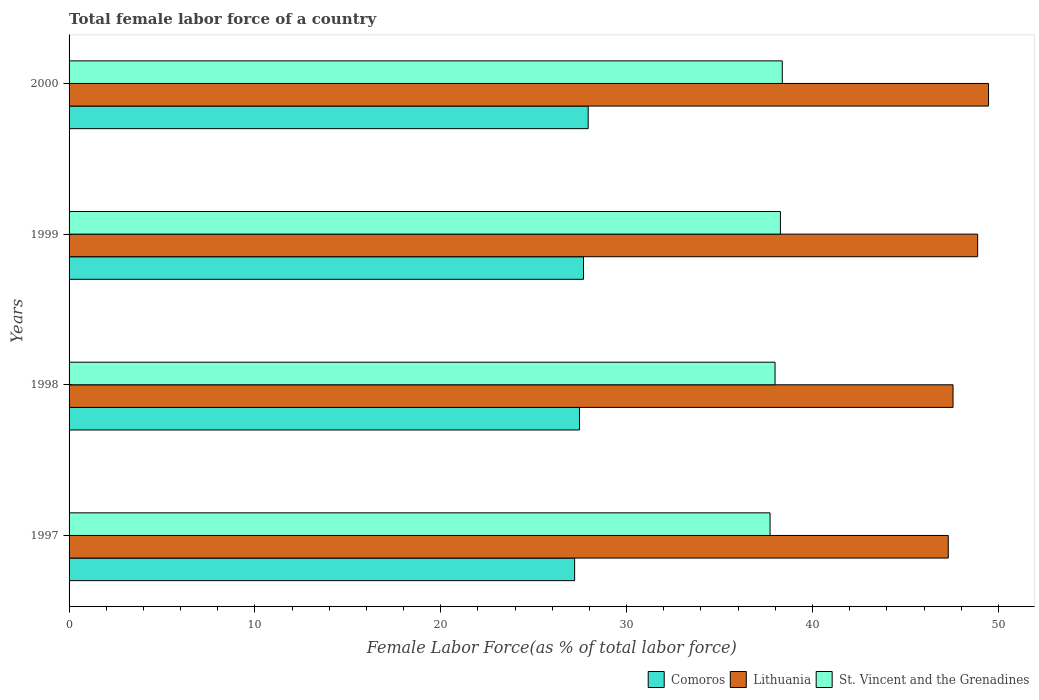How many different coloured bars are there?
Offer a very short reply. 3. How many bars are there on the 2nd tick from the top?
Your response must be concise. 3. What is the label of the 3rd group of bars from the top?
Make the answer very short. 1998. What is the percentage of female labor force in Lithuania in 1997?
Make the answer very short. 47.31. Across all years, what is the maximum percentage of female labor force in Lithuania?
Offer a terse response. 49.47. Across all years, what is the minimum percentage of female labor force in Lithuania?
Your answer should be compact. 47.31. What is the total percentage of female labor force in Lithuania in the graph?
Ensure brevity in your answer.  193.22. What is the difference between the percentage of female labor force in Comoros in 1997 and that in 1999?
Keep it short and to the point. -0.48. What is the difference between the percentage of female labor force in Lithuania in 1998 and the percentage of female labor force in Comoros in 1999?
Offer a terse response. 19.88. What is the average percentage of female labor force in Comoros per year?
Offer a very short reply. 27.57. In the year 1998, what is the difference between the percentage of female labor force in Comoros and percentage of female labor force in Lithuania?
Offer a terse response. -20.1. What is the ratio of the percentage of female labor force in Lithuania in 1999 to that in 2000?
Your answer should be compact. 0.99. Is the difference between the percentage of female labor force in Comoros in 1999 and 2000 greater than the difference between the percentage of female labor force in Lithuania in 1999 and 2000?
Provide a succinct answer. Yes. What is the difference between the highest and the second highest percentage of female labor force in St. Vincent and the Grenadines?
Provide a succinct answer. 0.1. What is the difference between the highest and the lowest percentage of female labor force in Comoros?
Offer a very short reply. 0.73. What does the 1st bar from the top in 1999 represents?
Ensure brevity in your answer.  St. Vincent and the Grenadines. What does the 1st bar from the bottom in 2000 represents?
Your answer should be very brief. Comoros. Is it the case that in every year, the sum of the percentage of female labor force in Lithuania and percentage of female labor force in St. Vincent and the Grenadines is greater than the percentage of female labor force in Comoros?
Your response must be concise. Yes. How many bars are there?
Provide a succinct answer. 12. What is the difference between two consecutive major ticks on the X-axis?
Offer a terse response. 10. Are the values on the major ticks of X-axis written in scientific E-notation?
Provide a short and direct response. No. Does the graph contain any zero values?
Offer a terse response. No. Where does the legend appear in the graph?
Your answer should be compact. Bottom right. How are the legend labels stacked?
Offer a terse response. Horizontal. What is the title of the graph?
Ensure brevity in your answer.  Total female labor force of a country. What is the label or title of the X-axis?
Offer a very short reply. Female Labor Force(as % of total labor force). What is the Female Labor Force(as % of total labor force) of Comoros in 1997?
Your response must be concise. 27.2. What is the Female Labor Force(as % of total labor force) in Lithuania in 1997?
Your response must be concise. 47.31. What is the Female Labor Force(as % of total labor force) in St. Vincent and the Grenadines in 1997?
Ensure brevity in your answer.  37.72. What is the Female Labor Force(as % of total labor force) of Comoros in 1998?
Keep it short and to the point. 27.47. What is the Female Labor Force(as % of total labor force) of Lithuania in 1998?
Provide a short and direct response. 47.56. What is the Female Labor Force(as % of total labor force) of St. Vincent and the Grenadines in 1998?
Your response must be concise. 37.99. What is the Female Labor Force(as % of total labor force) in Comoros in 1999?
Ensure brevity in your answer.  27.68. What is the Female Labor Force(as % of total labor force) of Lithuania in 1999?
Provide a short and direct response. 48.89. What is the Female Labor Force(as % of total labor force) in St. Vincent and the Grenadines in 1999?
Provide a short and direct response. 38.27. What is the Female Labor Force(as % of total labor force) of Comoros in 2000?
Provide a succinct answer. 27.93. What is the Female Labor Force(as % of total labor force) in Lithuania in 2000?
Make the answer very short. 49.47. What is the Female Labor Force(as % of total labor force) of St. Vincent and the Grenadines in 2000?
Provide a short and direct response. 38.37. Across all years, what is the maximum Female Labor Force(as % of total labor force) of Comoros?
Offer a terse response. 27.93. Across all years, what is the maximum Female Labor Force(as % of total labor force) in Lithuania?
Make the answer very short. 49.47. Across all years, what is the maximum Female Labor Force(as % of total labor force) in St. Vincent and the Grenadines?
Make the answer very short. 38.37. Across all years, what is the minimum Female Labor Force(as % of total labor force) in Comoros?
Provide a short and direct response. 27.2. Across all years, what is the minimum Female Labor Force(as % of total labor force) of Lithuania?
Provide a succinct answer. 47.31. Across all years, what is the minimum Female Labor Force(as % of total labor force) in St. Vincent and the Grenadines?
Your response must be concise. 37.72. What is the total Female Labor Force(as % of total labor force) of Comoros in the graph?
Your response must be concise. 110.28. What is the total Female Labor Force(as % of total labor force) in Lithuania in the graph?
Provide a succinct answer. 193.22. What is the total Female Labor Force(as % of total labor force) in St. Vincent and the Grenadines in the graph?
Offer a terse response. 152.35. What is the difference between the Female Labor Force(as % of total labor force) in Comoros in 1997 and that in 1998?
Make the answer very short. -0.26. What is the difference between the Female Labor Force(as % of total labor force) of Lithuania in 1997 and that in 1998?
Your answer should be compact. -0.26. What is the difference between the Female Labor Force(as % of total labor force) of St. Vincent and the Grenadines in 1997 and that in 1998?
Provide a short and direct response. -0.27. What is the difference between the Female Labor Force(as % of total labor force) of Comoros in 1997 and that in 1999?
Make the answer very short. -0.48. What is the difference between the Female Labor Force(as % of total labor force) of Lithuania in 1997 and that in 1999?
Offer a terse response. -1.58. What is the difference between the Female Labor Force(as % of total labor force) of St. Vincent and the Grenadines in 1997 and that in 1999?
Offer a very short reply. -0.56. What is the difference between the Female Labor Force(as % of total labor force) of Comoros in 1997 and that in 2000?
Your answer should be very brief. -0.73. What is the difference between the Female Labor Force(as % of total labor force) in Lithuania in 1997 and that in 2000?
Your response must be concise. -2.17. What is the difference between the Female Labor Force(as % of total labor force) in St. Vincent and the Grenadines in 1997 and that in 2000?
Your response must be concise. -0.66. What is the difference between the Female Labor Force(as % of total labor force) of Comoros in 1998 and that in 1999?
Keep it short and to the point. -0.21. What is the difference between the Female Labor Force(as % of total labor force) of Lithuania in 1998 and that in 1999?
Your response must be concise. -1.32. What is the difference between the Female Labor Force(as % of total labor force) in St. Vincent and the Grenadines in 1998 and that in 1999?
Offer a very short reply. -0.29. What is the difference between the Female Labor Force(as % of total labor force) of Comoros in 1998 and that in 2000?
Offer a terse response. -0.47. What is the difference between the Female Labor Force(as % of total labor force) of Lithuania in 1998 and that in 2000?
Your response must be concise. -1.91. What is the difference between the Female Labor Force(as % of total labor force) of St. Vincent and the Grenadines in 1998 and that in 2000?
Your answer should be very brief. -0.39. What is the difference between the Female Labor Force(as % of total labor force) of Comoros in 1999 and that in 2000?
Your answer should be compact. -0.25. What is the difference between the Female Labor Force(as % of total labor force) of Lithuania in 1999 and that in 2000?
Ensure brevity in your answer.  -0.58. What is the difference between the Female Labor Force(as % of total labor force) of St. Vincent and the Grenadines in 1999 and that in 2000?
Ensure brevity in your answer.  -0.1. What is the difference between the Female Labor Force(as % of total labor force) of Comoros in 1997 and the Female Labor Force(as % of total labor force) of Lithuania in 1998?
Offer a terse response. -20.36. What is the difference between the Female Labor Force(as % of total labor force) in Comoros in 1997 and the Female Labor Force(as % of total labor force) in St. Vincent and the Grenadines in 1998?
Provide a succinct answer. -10.78. What is the difference between the Female Labor Force(as % of total labor force) in Lithuania in 1997 and the Female Labor Force(as % of total labor force) in St. Vincent and the Grenadines in 1998?
Ensure brevity in your answer.  9.32. What is the difference between the Female Labor Force(as % of total labor force) in Comoros in 1997 and the Female Labor Force(as % of total labor force) in Lithuania in 1999?
Give a very brief answer. -21.68. What is the difference between the Female Labor Force(as % of total labor force) of Comoros in 1997 and the Female Labor Force(as % of total labor force) of St. Vincent and the Grenadines in 1999?
Give a very brief answer. -11.07. What is the difference between the Female Labor Force(as % of total labor force) of Lithuania in 1997 and the Female Labor Force(as % of total labor force) of St. Vincent and the Grenadines in 1999?
Give a very brief answer. 9.03. What is the difference between the Female Labor Force(as % of total labor force) of Comoros in 1997 and the Female Labor Force(as % of total labor force) of Lithuania in 2000?
Ensure brevity in your answer.  -22.27. What is the difference between the Female Labor Force(as % of total labor force) in Comoros in 1997 and the Female Labor Force(as % of total labor force) in St. Vincent and the Grenadines in 2000?
Provide a short and direct response. -11.17. What is the difference between the Female Labor Force(as % of total labor force) of Lithuania in 1997 and the Female Labor Force(as % of total labor force) of St. Vincent and the Grenadines in 2000?
Provide a short and direct response. 8.93. What is the difference between the Female Labor Force(as % of total labor force) in Comoros in 1998 and the Female Labor Force(as % of total labor force) in Lithuania in 1999?
Provide a short and direct response. -21.42. What is the difference between the Female Labor Force(as % of total labor force) of Comoros in 1998 and the Female Labor Force(as % of total labor force) of St. Vincent and the Grenadines in 1999?
Give a very brief answer. -10.81. What is the difference between the Female Labor Force(as % of total labor force) of Lithuania in 1998 and the Female Labor Force(as % of total labor force) of St. Vincent and the Grenadines in 1999?
Your answer should be compact. 9.29. What is the difference between the Female Labor Force(as % of total labor force) in Comoros in 1998 and the Female Labor Force(as % of total labor force) in Lithuania in 2000?
Provide a short and direct response. -22.01. What is the difference between the Female Labor Force(as % of total labor force) of Comoros in 1998 and the Female Labor Force(as % of total labor force) of St. Vincent and the Grenadines in 2000?
Keep it short and to the point. -10.91. What is the difference between the Female Labor Force(as % of total labor force) in Lithuania in 1998 and the Female Labor Force(as % of total labor force) in St. Vincent and the Grenadines in 2000?
Offer a very short reply. 9.19. What is the difference between the Female Labor Force(as % of total labor force) in Comoros in 1999 and the Female Labor Force(as % of total labor force) in Lithuania in 2000?
Provide a short and direct response. -21.79. What is the difference between the Female Labor Force(as % of total labor force) of Comoros in 1999 and the Female Labor Force(as % of total labor force) of St. Vincent and the Grenadines in 2000?
Your answer should be very brief. -10.7. What is the difference between the Female Labor Force(as % of total labor force) of Lithuania in 1999 and the Female Labor Force(as % of total labor force) of St. Vincent and the Grenadines in 2000?
Keep it short and to the point. 10.51. What is the average Female Labor Force(as % of total labor force) in Comoros per year?
Your answer should be compact. 27.57. What is the average Female Labor Force(as % of total labor force) of Lithuania per year?
Your answer should be very brief. 48.31. What is the average Female Labor Force(as % of total labor force) of St. Vincent and the Grenadines per year?
Provide a short and direct response. 38.09. In the year 1997, what is the difference between the Female Labor Force(as % of total labor force) in Comoros and Female Labor Force(as % of total labor force) in Lithuania?
Ensure brevity in your answer.  -20.1. In the year 1997, what is the difference between the Female Labor Force(as % of total labor force) in Comoros and Female Labor Force(as % of total labor force) in St. Vincent and the Grenadines?
Keep it short and to the point. -10.52. In the year 1997, what is the difference between the Female Labor Force(as % of total labor force) in Lithuania and Female Labor Force(as % of total labor force) in St. Vincent and the Grenadines?
Offer a very short reply. 9.59. In the year 1998, what is the difference between the Female Labor Force(as % of total labor force) of Comoros and Female Labor Force(as % of total labor force) of Lithuania?
Your answer should be very brief. -20.1. In the year 1998, what is the difference between the Female Labor Force(as % of total labor force) in Comoros and Female Labor Force(as % of total labor force) in St. Vincent and the Grenadines?
Offer a very short reply. -10.52. In the year 1998, what is the difference between the Female Labor Force(as % of total labor force) of Lithuania and Female Labor Force(as % of total labor force) of St. Vincent and the Grenadines?
Make the answer very short. 9.58. In the year 1999, what is the difference between the Female Labor Force(as % of total labor force) in Comoros and Female Labor Force(as % of total labor force) in Lithuania?
Your answer should be very brief. -21.21. In the year 1999, what is the difference between the Female Labor Force(as % of total labor force) in Comoros and Female Labor Force(as % of total labor force) in St. Vincent and the Grenadines?
Your answer should be compact. -10.6. In the year 1999, what is the difference between the Female Labor Force(as % of total labor force) of Lithuania and Female Labor Force(as % of total labor force) of St. Vincent and the Grenadines?
Your answer should be compact. 10.61. In the year 2000, what is the difference between the Female Labor Force(as % of total labor force) in Comoros and Female Labor Force(as % of total labor force) in Lithuania?
Offer a terse response. -21.54. In the year 2000, what is the difference between the Female Labor Force(as % of total labor force) in Comoros and Female Labor Force(as % of total labor force) in St. Vincent and the Grenadines?
Keep it short and to the point. -10.44. In the year 2000, what is the difference between the Female Labor Force(as % of total labor force) in Lithuania and Female Labor Force(as % of total labor force) in St. Vincent and the Grenadines?
Make the answer very short. 11.1. What is the ratio of the Female Labor Force(as % of total labor force) of Lithuania in 1997 to that in 1998?
Give a very brief answer. 0.99. What is the ratio of the Female Labor Force(as % of total labor force) of St. Vincent and the Grenadines in 1997 to that in 1998?
Provide a succinct answer. 0.99. What is the ratio of the Female Labor Force(as % of total labor force) in Comoros in 1997 to that in 1999?
Provide a succinct answer. 0.98. What is the ratio of the Female Labor Force(as % of total labor force) in Lithuania in 1997 to that in 1999?
Make the answer very short. 0.97. What is the ratio of the Female Labor Force(as % of total labor force) in St. Vincent and the Grenadines in 1997 to that in 1999?
Keep it short and to the point. 0.99. What is the ratio of the Female Labor Force(as % of total labor force) in Comoros in 1997 to that in 2000?
Keep it short and to the point. 0.97. What is the ratio of the Female Labor Force(as % of total labor force) of Lithuania in 1997 to that in 2000?
Your response must be concise. 0.96. What is the ratio of the Female Labor Force(as % of total labor force) of St. Vincent and the Grenadines in 1997 to that in 2000?
Give a very brief answer. 0.98. What is the ratio of the Female Labor Force(as % of total labor force) of Comoros in 1998 to that in 1999?
Ensure brevity in your answer.  0.99. What is the ratio of the Female Labor Force(as % of total labor force) in Lithuania in 1998 to that in 1999?
Make the answer very short. 0.97. What is the ratio of the Female Labor Force(as % of total labor force) of Comoros in 1998 to that in 2000?
Provide a succinct answer. 0.98. What is the ratio of the Female Labor Force(as % of total labor force) in Lithuania in 1998 to that in 2000?
Keep it short and to the point. 0.96. What is the ratio of the Female Labor Force(as % of total labor force) of Lithuania in 1999 to that in 2000?
Give a very brief answer. 0.99. What is the difference between the highest and the second highest Female Labor Force(as % of total labor force) of Comoros?
Your answer should be very brief. 0.25. What is the difference between the highest and the second highest Female Labor Force(as % of total labor force) of Lithuania?
Provide a short and direct response. 0.58. What is the difference between the highest and the second highest Female Labor Force(as % of total labor force) in St. Vincent and the Grenadines?
Make the answer very short. 0.1. What is the difference between the highest and the lowest Female Labor Force(as % of total labor force) of Comoros?
Provide a short and direct response. 0.73. What is the difference between the highest and the lowest Female Labor Force(as % of total labor force) of Lithuania?
Your answer should be compact. 2.17. What is the difference between the highest and the lowest Female Labor Force(as % of total labor force) of St. Vincent and the Grenadines?
Give a very brief answer. 0.66. 